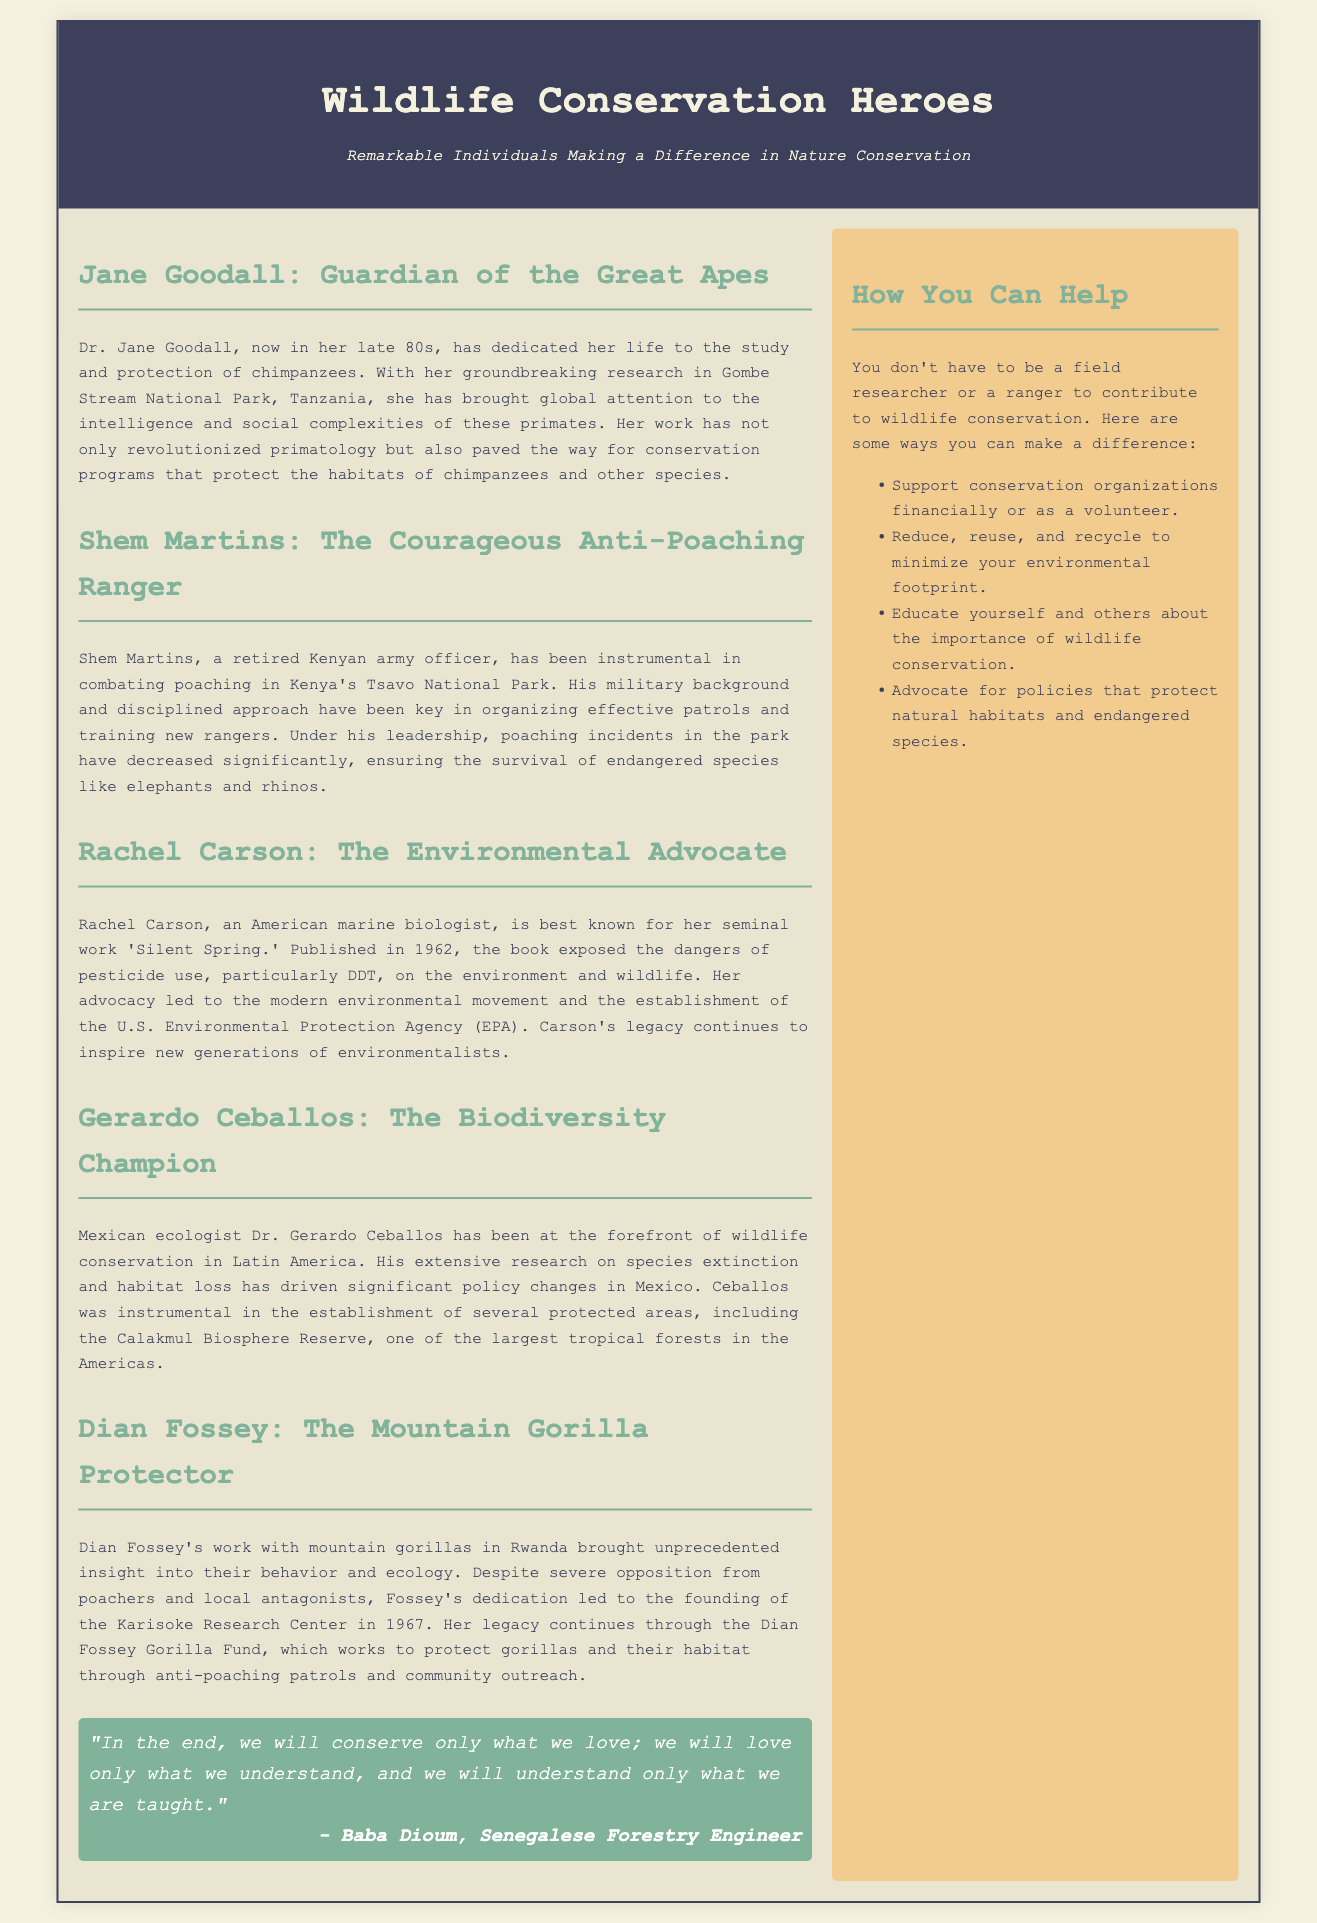What is the title of the main article? The title of the main article is displayed prominently at the top of the newspaper layout.
Answer: Wildlife Conservation Heroes Who is the guardian of the great apes? This question pertains to the specific individual highlighted in one of the articles about wildlife conservation.
Answer: Jane Goodall Which park does Shem Martins work to protect? The location where Shem Martins has been actively engaged in anti-poaching efforts is mentioned in his article.
Answer: Tsavo National Park What significant environmental book did Rachel Carson write? The document lists a notable publication attributed to Rachel Carson, key to her advocacy.
Answer: Silent Spring How did Gerardo Ceballos contribute to conservation? This question refers to the impact of Dr. Ceballos's work on specific conservation efforts mentioned in the article.
Answer: Policy changes What year was the Karisoke Research Center founded? The document contains the year associated with the establishment of a significant research center for gorillas.
Answer: 1967 Name one way to help wildlife conservation mentioned in the sidebar. The sidebar lists practical actions individuals can take to contribute to wildlife conservation efforts.
Answer: Support conservation organizations Who is the author of the quote included in the document? The document attributes a meaningful quote to a specific individual, which highlights the theme of conservation.
Answer: Baba Dioum What does the subtitle of the newspaper layout describe? The subtitle provides insight into the focus and key theme of the content presented in the document.
Answer: Remarkable Individuals Making a Difference in Nature Conservation 